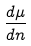<formula> <loc_0><loc_0><loc_500><loc_500>\frac { d \mu } { d n }</formula> 